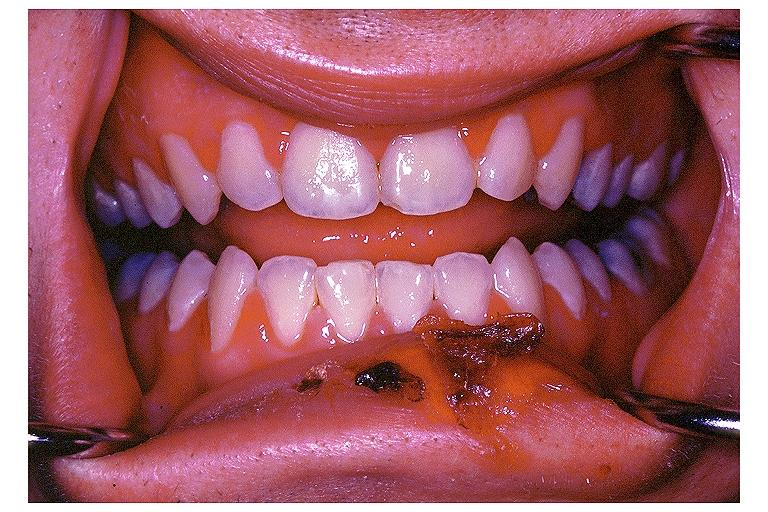what does this image show?
Answer the question using a single word or phrase. Primary herpetic gingivo-stomatitis 